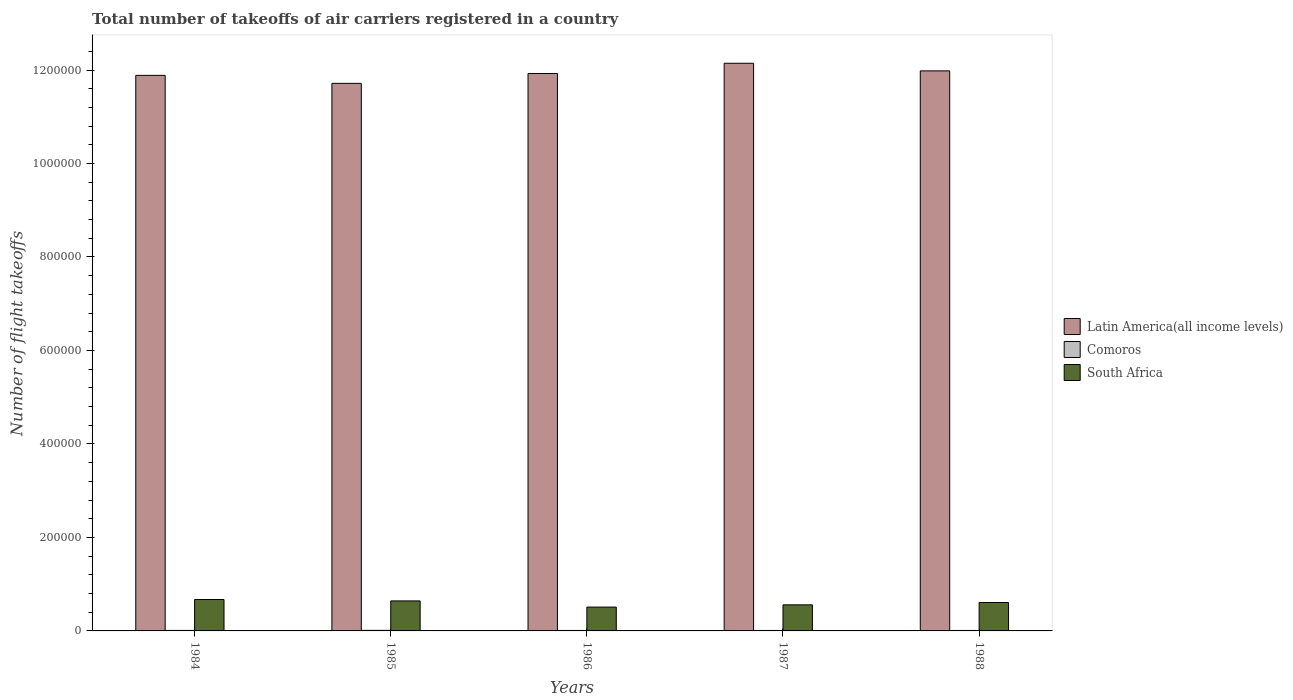How many groups of bars are there?
Make the answer very short. 5. Are the number of bars per tick equal to the number of legend labels?
Give a very brief answer. Yes. Are the number of bars on each tick of the X-axis equal?
Ensure brevity in your answer.  Yes. What is the label of the 4th group of bars from the left?
Your response must be concise. 1987. What is the total number of flight takeoffs in Comoros in 1984?
Give a very brief answer. 1100. Across all years, what is the maximum total number of flight takeoffs in South Africa?
Provide a succinct answer. 6.72e+04. Across all years, what is the minimum total number of flight takeoffs in Latin America(all income levels)?
Give a very brief answer. 1.17e+06. In which year was the total number of flight takeoffs in Comoros maximum?
Keep it short and to the point. 1985. What is the total total number of flight takeoffs in Comoros in the graph?
Offer a terse response. 5300. What is the difference between the total number of flight takeoffs in Latin America(all income levels) in 1985 and that in 1987?
Your response must be concise. -4.30e+04. What is the difference between the total number of flight takeoffs in Comoros in 1988 and the total number of flight takeoffs in South Africa in 1985?
Ensure brevity in your answer.  -6.32e+04. What is the average total number of flight takeoffs in Comoros per year?
Ensure brevity in your answer.  1060. In the year 1988, what is the difference between the total number of flight takeoffs in Comoros and total number of flight takeoffs in South Africa?
Give a very brief answer. -5.98e+04. What is the ratio of the total number of flight takeoffs in Latin America(all income levels) in 1986 to that in 1987?
Provide a succinct answer. 0.98. Is the difference between the total number of flight takeoffs in Comoros in 1984 and 1985 greater than the difference between the total number of flight takeoffs in South Africa in 1984 and 1985?
Provide a short and direct response. No. What is the difference between the highest and the second highest total number of flight takeoffs in South Africa?
Offer a very short reply. 3000. What is the difference between the highest and the lowest total number of flight takeoffs in Latin America(all income levels)?
Ensure brevity in your answer.  4.30e+04. In how many years, is the total number of flight takeoffs in South Africa greater than the average total number of flight takeoffs in South Africa taken over all years?
Provide a short and direct response. 3. What does the 1st bar from the left in 1985 represents?
Keep it short and to the point. Latin America(all income levels). What does the 2nd bar from the right in 1985 represents?
Ensure brevity in your answer.  Comoros. How many years are there in the graph?
Provide a succinct answer. 5. Does the graph contain grids?
Provide a short and direct response. No. How many legend labels are there?
Provide a succinct answer. 3. What is the title of the graph?
Give a very brief answer. Total number of takeoffs of air carriers registered in a country. What is the label or title of the Y-axis?
Give a very brief answer. Number of flight takeoffs. What is the Number of flight takeoffs of Latin America(all income levels) in 1984?
Provide a short and direct response. 1.19e+06. What is the Number of flight takeoffs in Comoros in 1984?
Your answer should be compact. 1100. What is the Number of flight takeoffs of South Africa in 1984?
Your answer should be compact. 6.72e+04. What is the Number of flight takeoffs of Latin America(all income levels) in 1985?
Provide a short and direct response. 1.17e+06. What is the Number of flight takeoffs in Comoros in 1985?
Your response must be concise. 1200. What is the Number of flight takeoffs in South Africa in 1985?
Your answer should be very brief. 6.42e+04. What is the Number of flight takeoffs of Latin America(all income levels) in 1986?
Provide a short and direct response. 1.19e+06. What is the Number of flight takeoffs of Comoros in 1986?
Provide a short and direct response. 1000. What is the Number of flight takeoffs in South Africa in 1986?
Ensure brevity in your answer.  5.10e+04. What is the Number of flight takeoffs in Latin America(all income levels) in 1987?
Offer a terse response. 1.21e+06. What is the Number of flight takeoffs of Comoros in 1987?
Your answer should be compact. 1000. What is the Number of flight takeoffs of South Africa in 1987?
Make the answer very short. 5.58e+04. What is the Number of flight takeoffs in Latin America(all income levels) in 1988?
Keep it short and to the point. 1.20e+06. What is the Number of flight takeoffs of Comoros in 1988?
Provide a succinct answer. 1000. What is the Number of flight takeoffs in South Africa in 1988?
Provide a short and direct response. 6.08e+04. Across all years, what is the maximum Number of flight takeoffs in Latin America(all income levels)?
Your response must be concise. 1.21e+06. Across all years, what is the maximum Number of flight takeoffs in Comoros?
Provide a succinct answer. 1200. Across all years, what is the maximum Number of flight takeoffs in South Africa?
Offer a very short reply. 6.72e+04. Across all years, what is the minimum Number of flight takeoffs of Latin America(all income levels)?
Offer a terse response. 1.17e+06. Across all years, what is the minimum Number of flight takeoffs of Comoros?
Keep it short and to the point. 1000. Across all years, what is the minimum Number of flight takeoffs in South Africa?
Offer a terse response. 5.10e+04. What is the total Number of flight takeoffs in Latin America(all income levels) in the graph?
Keep it short and to the point. 5.97e+06. What is the total Number of flight takeoffs of Comoros in the graph?
Make the answer very short. 5300. What is the total Number of flight takeoffs in South Africa in the graph?
Provide a succinct answer. 2.99e+05. What is the difference between the Number of flight takeoffs in Latin America(all income levels) in 1984 and that in 1985?
Offer a terse response. 1.71e+04. What is the difference between the Number of flight takeoffs of Comoros in 1984 and that in 1985?
Your response must be concise. -100. What is the difference between the Number of flight takeoffs in South Africa in 1984 and that in 1985?
Provide a short and direct response. 3000. What is the difference between the Number of flight takeoffs of Latin America(all income levels) in 1984 and that in 1986?
Make the answer very short. -4000. What is the difference between the Number of flight takeoffs in South Africa in 1984 and that in 1986?
Make the answer very short. 1.62e+04. What is the difference between the Number of flight takeoffs in Latin America(all income levels) in 1984 and that in 1987?
Provide a short and direct response. -2.59e+04. What is the difference between the Number of flight takeoffs of Comoros in 1984 and that in 1987?
Your answer should be compact. 100. What is the difference between the Number of flight takeoffs of South Africa in 1984 and that in 1987?
Keep it short and to the point. 1.14e+04. What is the difference between the Number of flight takeoffs of Latin America(all income levels) in 1984 and that in 1988?
Ensure brevity in your answer.  -9600. What is the difference between the Number of flight takeoffs of South Africa in 1984 and that in 1988?
Your response must be concise. 6400. What is the difference between the Number of flight takeoffs of Latin America(all income levels) in 1985 and that in 1986?
Provide a short and direct response. -2.11e+04. What is the difference between the Number of flight takeoffs of South Africa in 1985 and that in 1986?
Your answer should be compact. 1.32e+04. What is the difference between the Number of flight takeoffs of Latin America(all income levels) in 1985 and that in 1987?
Keep it short and to the point. -4.30e+04. What is the difference between the Number of flight takeoffs of South Africa in 1985 and that in 1987?
Provide a succinct answer. 8400. What is the difference between the Number of flight takeoffs of Latin America(all income levels) in 1985 and that in 1988?
Your answer should be compact. -2.67e+04. What is the difference between the Number of flight takeoffs in Comoros in 1985 and that in 1988?
Your answer should be very brief. 200. What is the difference between the Number of flight takeoffs in South Africa in 1985 and that in 1988?
Ensure brevity in your answer.  3400. What is the difference between the Number of flight takeoffs in Latin America(all income levels) in 1986 and that in 1987?
Make the answer very short. -2.19e+04. What is the difference between the Number of flight takeoffs of South Africa in 1986 and that in 1987?
Offer a terse response. -4800. What is the difference between the Number of flight takeoffs in Latin America(all income levels) in 1986 and that in 1988?
Provide a short and direct response. -5600. What is the difference between the Number of flight takeoffs of South Africa in 1986 and that in 1988?
Provide a succinct answer. -9800. What is the difference between the Number of flight takeoffs of Latin America(all income levels) in 1987 and that in 1988?
Your answer should be compact. 1.63e+04. What is the difference between the Number of flight takeoffs in Comoros in 1987 and that in 1988?
Ensure brevity in your answer.  0. What is the difference between the Number of flight takeoffs of South Africa in 1987 and that in 1988?
Make the answer very short. -5000. What is the difference between the Number of flight takeoffs of Latin America(all income levels) in 1984 and the Number of flight takeoffs of Comoros in 1985?
Your response must be concise. 1.19e+06. What is the difference between the Number of flight takeoffs of Latin America(all income levels) in 1984 and the Number of flight takeoffs of South Africa in 1985?
Your answer should be compact. 1.12e+06. What is the difference between the Number of flight takeoffs of Comoros in 1984 and the Number of flight takeoffs of South Africa in 1985?
Ensure brevity in your answer.  -6.31e+04. What is the difference between the Number of flight takeoffs in Latin America(all income levels) in 1984 and the Number of flight takeoffs in Comoros in 1986?
Your answer should be very brief. 1.19e+06. What is the difference between the Number of flight takeoffs of Latin America(all income levels) in 1984 and the Number of flight takeoffs of South Africa in 1986?
Give a very brief answer. 1.14e+06. What is the difference between the Number of flight takeoffs of Comoros in 1984 and the Number of flight takeoffs of South Africa in 1986?
Your answer should be very brief. -4.99e+04. What is the difference between the Number of flight takeoffs of Latin America(all income levels) in 1984 and the Number of flight takeoffs of Comoros in 1987?
Provide a succinct answer. 1.19e+06. What is the difference between the Number of flight takeoffs of Latin America(all income levels) in 1984 and the Number of flight takeoffs of South Africa in 1987?
Your response must be concise. 1.13e+06. What is the difference between the Number of flight takeoffs of Comoros in 1984 and the Number of flight takeoffs of South Africa in 1987?
Keep it short and to the point. -5.47e+04. What is the difference between the Number of flight takeoffs in Latin America(all income levels) in 1984 and the Number of flight takeoffs in Comoros in 1988?
Give a very brief answer. 1.19e+06. What is the difference between the Number of flight takeoffs of Latin America(all income levels) in 1984 and the Number of flight takeoffs of South Africa in 1988?
Provide a short and direct response. 1.13e+06. What is the difference between the Number of flight takeoffs in Comoros in 1984 and the Number of flight takeoffs in South Africa in 1988?
Keep it short and to the point. -5.97e+04. What is the difference between the Number of flight takeoffs of Latin America(all income levels) in 1985 and the Number of flight takeoffs of Comoros in 1986?
Offer a very short reply. 1.17e+06. What is the difference between the Number of flight takeoffs in Latin America(all income levels) in 1985 and the Number of flight takeoffs in South Africa in 1986?
Provide a short and direct response. 1.12e+06. What is the difference between the Number of flight takeoffs of Comoros in 1985 and the Number of flight takeoffs of South Africa in 1986?
Your answer should be very brief. -4.98e+04. What is the difference between the Number of flight takeoffs of Latin America(all income levels) in 1985 and the Number of flight takeoffs of Comoros in 1987?
Provide a short and direct response. 1.17e+06. What is the difference between the Number of flight takeoffs of Latin America(all income levels) in 1985 and the Number of flight takeoffs of South Africa in 1987?
Keep it short and to the point. 1.12e+06. What is the difference between the Number of flight takeoffs in Comoros in 1985 and the Number of flight takeoffs in South Africa in 1987?
Your answer should be compact. -5.46e+04. What is the difference between the Number of flight takeoffs of Latin America(all income levels) in 1985 and the Number of flight takeoffs of Comoros in 1988?
Your response must be concise. 1.17e+06. What is the difference between the Number of flight takeoffs in Latin America(all income levels) in 1985 and the Number of flight takeoffs in South Africa in 1988?
Offer a terse response. 1.11e+06. What is the difference between the Number of flight takeoffs of Comoros in 1985 and the Number of flight takeoffs of South Africa in 1988?
Provide a succinct answer. -5.96e+04. What is the difference between the Number of flight takeoffs of Latin America(all income levels) in 1986 and the Number of flight takeoffs of Comoros in 1987?
Offer a terse response. 1.19e+06. What is the difference between the Number of flight takeoffs in Latin America(all income levels) in 1986 and the Number of flight takeoffs in South Africa in 1987?
Keep it short and to the point. 1.14e+06. What is the difference between the Number of flight takeoffs of Comoros in 1986 and the Number of flight takeoffs of South Africa in 1987?
Ensure brevity in your answer.  -5.48e+04. What is the difference between the Number of flight takeoffs of Latin America(all income levels) in 1986 and the Number of flight takeoffs of Comoros in 1988?
Your answer should be very brief. 1.19e+06. What is the difference between the Number of flight takeoffs in Latin America(all income levels) in 1986 and the Number of flight takeoffs in South Africa in 1988?
Keep it short and to the point. 1.13e+06. What is the difference between the Number of flight takeoffs in Comoros in 1986 and the Number of flight takeoffs in South Africa in 1988?
Ensure brevity in your answer.  -5.98e+04. What is the difference between the Number of flight takeoffs in Latin America(all income levels) in 1987 and the Number of flight takeoffs in Comoros in 1988?
Make the answer very short. 1.21e+06. What is the difference between the Number of flight takeoffs in Latin America(all income levels) in 1987 and the Number of flight takeoffs in South Africa in 1988?
Ensure brevity in your answer.  1.15e+06. What is the difference between the Number of flight takeoffs of Comoros in 1987 and the Number of flight takeoffs of South Africa in 1988?
Keep it short and to the point. -5.98e+04. What is the average Number of flight takeoffs of Latin America(all income levels) per year?
Your answer should be very brief. 1.19e+06. What is the average Number of flight takeoffs of Comoros per year?
Offer a terse response. 1060. What is the average Number of flight takeoffs of South Africa per year?
Offer a very short reply. 5.98e+04. In the year 1984, what is the difference between the Number of flight takeoffs of Latin America(all income levels) and Number of flight takeoffs of Comoros?
Provide a succinct answer. 1.19e+06. In the year 1984, what is the difference between the Number of flight takeoffs in Latin America(all income levels) and Number of flight takeoffs in South Africa?
Your answer should be compact. 1.12e+06. In the year 1984, what is the difference between the Number of flight takeoffs in Comoros and Number of flight takeoffs in South Africa?
Ensure brevity in your answer.  -6.61e+04. In the year 1985, what is the difference between the Number of flight takeoffs of Latin America(all income levels) and Number of flight takeoffs of Comoros?
Ensure brevity in your answer.  1.17e+06. In the year 1985, what is the difference between the Number of flight takeoffs of Latin America(all income levels) and Number of flight takeoffs of South Africa?
Provide a succinct answer. 1.11e+06. In the year 1985, what is the difference between the Number of flight takeoffs of Comoros and Number of flight takeoffs of South Africa?
Keep it short and to the point. -6.30e+04. In the year 1986, what is the difference between the Number of flight takeoffs of Latin America(all income levels) and Number of flight takeoffs of Comoros?
Offer a very short reply. 1.19e+06. In the year 1986, what is the difference between the Number of flight takeoffs of Latin America(all income levels) and Number of flight takeoffs of South Africa?
Provide a succinct answer. 1.14e+06. In the year 1987, what is the difference between the Number of flight takeoffs in Latin America(all income levels) and Number of flight takeoffs in Comoros?
Ensure brevity in your answer.  1.21e+06. In the year 1987, what is the difference between the Number of flight takeoffs of Latin America(all income levels) and Number of flight takeoffs of South Africa?
Keep it short and to the point. 1.16e+06. In the year 1987, what is the difference between the Number of flight takeoffs in Comoros and Number of flight takeoffs in South Africa?
Offer a very short reply. -5.48e+04. In the year 1988, what is the difference between the Number of flight takeoffs in Latin America(all income levels) and Number of flight takeoffs in Comoros?
Offer a terse response. 1.20e+06. In the year 1988, what is the difference between the Number of flight takeoffs in Latin America(all income levels) and Number of flight takeoffs in South Africa?
Make the answer very short. 1.14e+06. In the year 1988, what is the difference between the Number of flight takeoffs of Comoros and Number of flight takeoffs of South Africa?
Offer a terse response. -5.98e+04. What is the ratio of the Number of flight takeoffs in Latin America(all income levels) in 1984 to that in 1985?
Keep it short and to the point. 1.01. What is the ratio of the Number of flight takeoffs in Comoros in 1984 to that in 1985?
Offer a very short reply. 0.92. What is the ratio of the Number of flight takeoffs of South Africa in 1984 to that in 1985?
Provide a short and direct response. 1.05. What is the ratio of the Number of flight takeoffs of Comoros in 1984 to that in 1986?
Provide a succinct answer. 1.1. What is the ratio of the Number of flight takeoffs of South Africa in 1984 to that in 1986?
Your answer should be compact. 1.32. What is the ratio of the Number of flight takeoffs in Latin America(all income levels) in 1984 to that in 1987?
Your answer should be compact. 0.98. What is the ratio of the Number of flight takeoffs in Comoros in 1984 to that in 1987?
Offer a very short reply. 1.1. What is the ratio of the Number of flight takeoffs in South Africa in 1984 to that in 1987?
Make the answer very short. 1.2. What is the ratio of the Number of flight takeoffs of Latin America(all income levels) in 1984 to that in 1988?
Your answer should be compact. 0.99. What is the ratio of the Number of flight takeoffs in South Africa in 1984 to that in 1988?
Keep it short and to the point. 1.11. What is the ratio of the Number of flight takeoffs in Latin America(all income levels) in 1985 to that in 1986?
Your answer should be compact. 0.98. What is the ratio of the Number of flight takeoffs of South Africa in 1985 to that in 1986?
Provide a short and direct response. 1.26. What is the ratio of the Number of flight takeoffs of Latin America(all income levels) in 1985 to that in 1987?
Make the answer very short. 0.96. What is the ratio of the Number of flight takeoffs of Comoros in 1985 to that in 1987?
Make the answer very short. 1.2. What is the ratio of the Number of flight takeoffs in South Africa in 1985 to that in 1987?
Offer a terse response. 1.15. What is the ratio of the Number of flight takeoffs in Latin America(all income levels) in 1985 to that in 1988?
Provide a succinct answer. 0.98. What is the ratio of the Number of flight takeoffs of Comoros in 1985 to that in 1988?
Provide a succinct answer. 1.2. What is the ratio of the Number of flight takeoffs in South Africa in 1985 to that in 1988?
Keep it short and to the point. 1.06. What is the ratio of the Number of flight takeoffs of Latin America(all income levels) in 1986 to that in 1987?
Provide a succinct answer. 0.98. What is the ratio of the Number of flight takeoffs of Comoros in 1986 to that in 1987?
Provide a short and direct response. 1. What is the ratio of the Number of flight takeoffs of South Africa in 1986 to that in 1987?
Give a very brief answer. 0.91. What is the ratio of the Number of flight takeoffs in Latin America(all income levels) in 1986 to that in 1988?
Give a very brief answer. 1. What is the ratio of the Number of flight takeoffs of Comoros in 1986 to that in 1988?
Give a very brief answer. 1. What is the ratio of the Number of flight takeoffs in South Africa in 1986 to that in 1988?
Provide a succinct answer. 0.84. What is the ratio of the Number of flight takeoffs in Latin America(all income levels) in 1987 to that in 1988?
Make the answer very short. 1.01. What is the ratio of the Number of flight takeoffs in Comoros in 1987 to that in 1988?
Keep it short and to the point. 1. What is the ratio of the Number of flight takeoffs of South Africa in 1987 to that in 1988?
Provide a succinct answer. 0.92. What is the difference between the highest and the second highest Number of flight takeoffs of Latin America(all income levels)?
Give a very brief answer. 1.63e+04. What is the difference between the highest and the second highest Number of flight takeoffs in South Africa?
Provide a succinct answer. 3000. What is the difference between the highest and the lowest Number of flight takeoffs of Latin America(all income levels)?
Your response must be concise. 4.30e+04. What is the difference between the highest and the lowest Number of flight takeoffs in South Africa?
Give a very brief answer. 1.62e+04. 